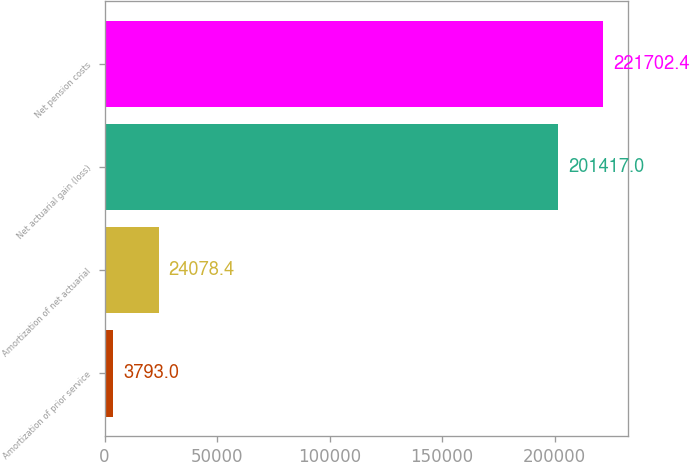<chart> <loc_0><loc_0><loc_500><loc_500><bar_chart><fcel>Amortization of prior service<fcel>Amortization of net actuarial<fcel>Net actuarial gain (loss)<fcel>Net pension costs<nl><fcel>3793<fcel>24078.4<fcel>201417<fcel>221702<nl></chart> 